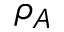<formula> <loc_0><loc_0><loc_500><loc_500>\rho _ { A }</formula> 